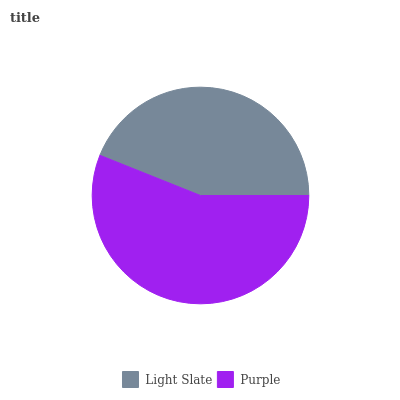Is Light Slate the minimum?
Answer yes or no. Yes. Is Purple the maximum?
Answer yes or no. Yes. Is Purple the minimum?
Answer yes or no. No. Is Purple greater than Light Slate?
Answer yes or no. Yes. Is Light Slate less than Purple?
Answer yes or no. Yes. Is Light Slate greater than Purple?
Answer yes or no. No. Is Purple less than Light Slate?
Answer yes or no. No. Is Purple the high median?
Answer yes or no. Yes. Is Light Slate the low median?
Answer yes or no. Yes. Is Light Slate the high median?
Answer yes or no. No. Is Purple the low median?
Answer yes or no. No. 